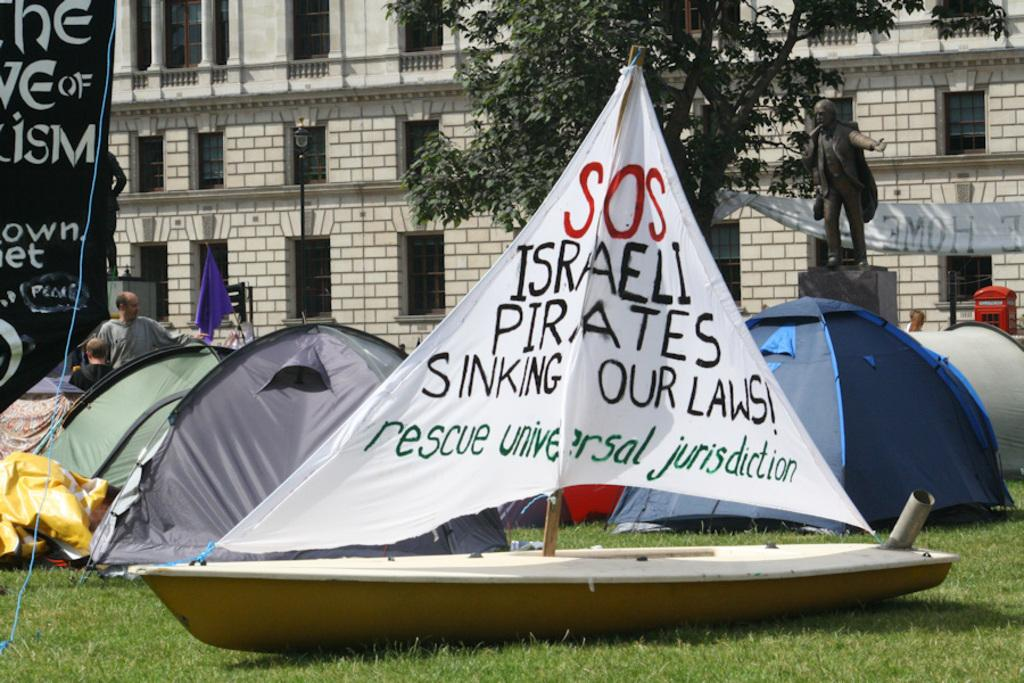What is the main subject of the image? The main subject of the image is a boat. What can be seen on the boat? There is text written on the cloth of the boat. What type of structures are present in the image? There are tents and a building in the image. What type of vegetation is visible in the image? There is a tree and grass in the image. What else can be seen in the image? There are people, other objects, and a tree in the image. How many bottles are being hammered on the range in the image? There are no bottles, hammers, or ranges present in the image. 